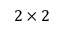Convert formula to latex. <formula><loc_0><loc_0><loc_500><loc_500>2 \times 2</formula> 